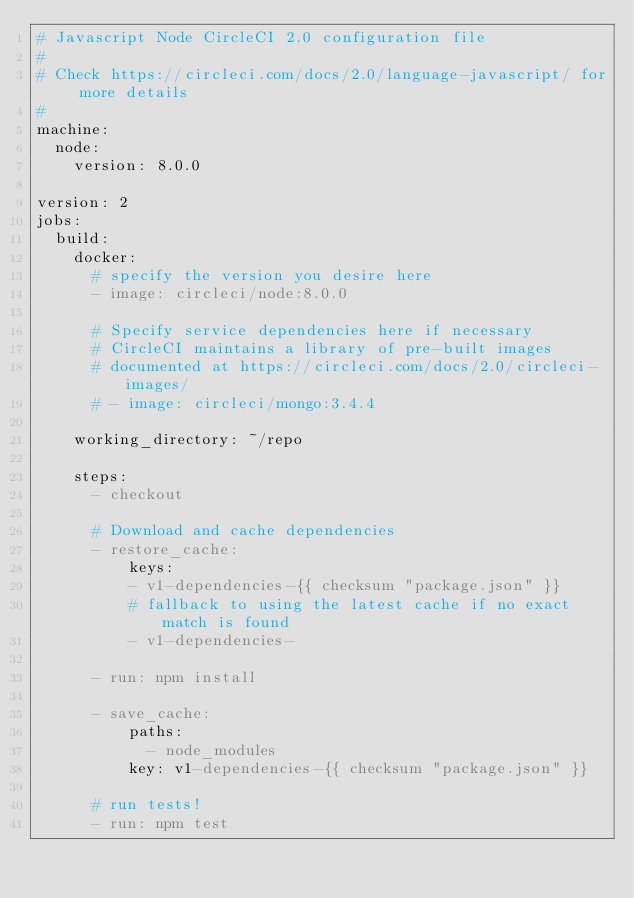Convert code to text. <code><loc_0><loc_0><loc_500><loc_500><_YAML_># Javascript Node CircleCI 2.0 configuration file
#
# Check https://circleci.com/docs/2.0/language-javascript/ for more details
#
machine:
  node:
    version: 8.0.0

version: 2
jobs:
  build:
    docker:
      # specify the version you desire here
      - image: circleci/node:8.0.0
      
      # Specify service dependencies here if necessary
      # CircleCI maintains a library of pre-built images
      # documented at https://circleci.com/docs/2.0/circleci-images/
      # - image: circleci/mongo:3.4.4

    working_directory: ~/repo

    steps:
      - checkout

      # Download and cache dependencies
      - restore_cache:
          keys:
          - v1-dependencies-{{ checksum "package.json" }}
          # fallback to using the latest cache if no exact match is found
          - v1-dependencies-

      - run: npm install

      - save_cache:
          paths:
            - node_modules
          key: v1-dependencies-{{ checksum "package.json" }}
        
      # run tests!
      - run: npm test


</code> 